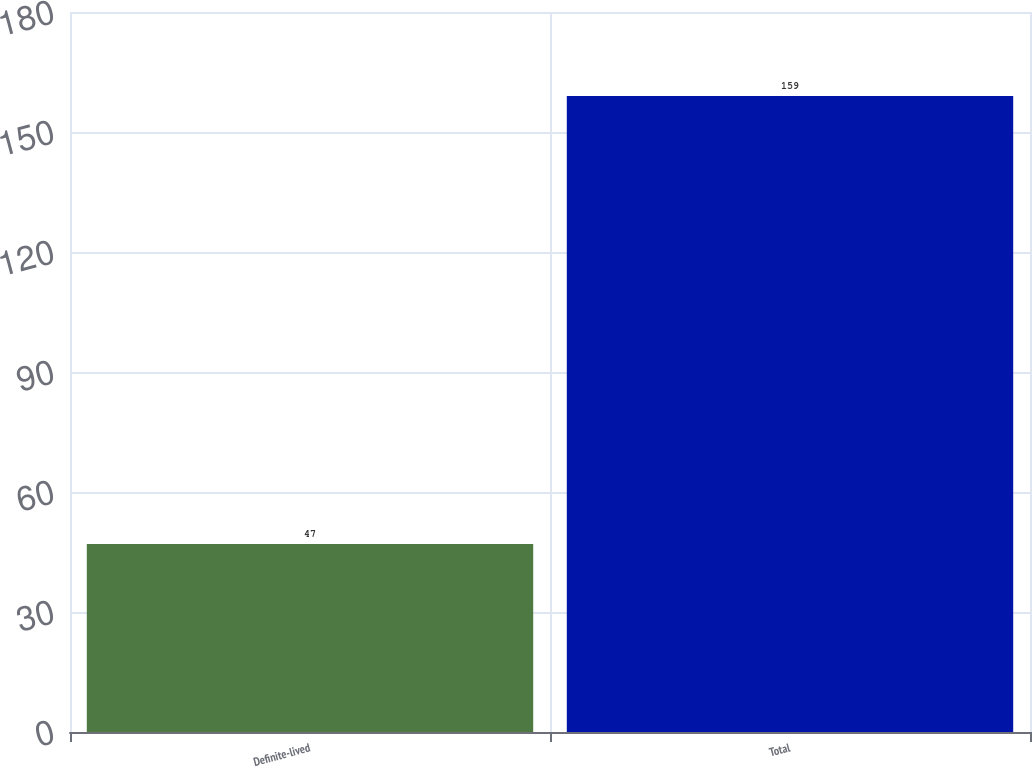<chart> <loc_0><loc_0><loc_500><loc_500><bar_chart><fcel>Definite-lived<fcel>Total<nl><fcel>47<fcel>159<nl></chart> 